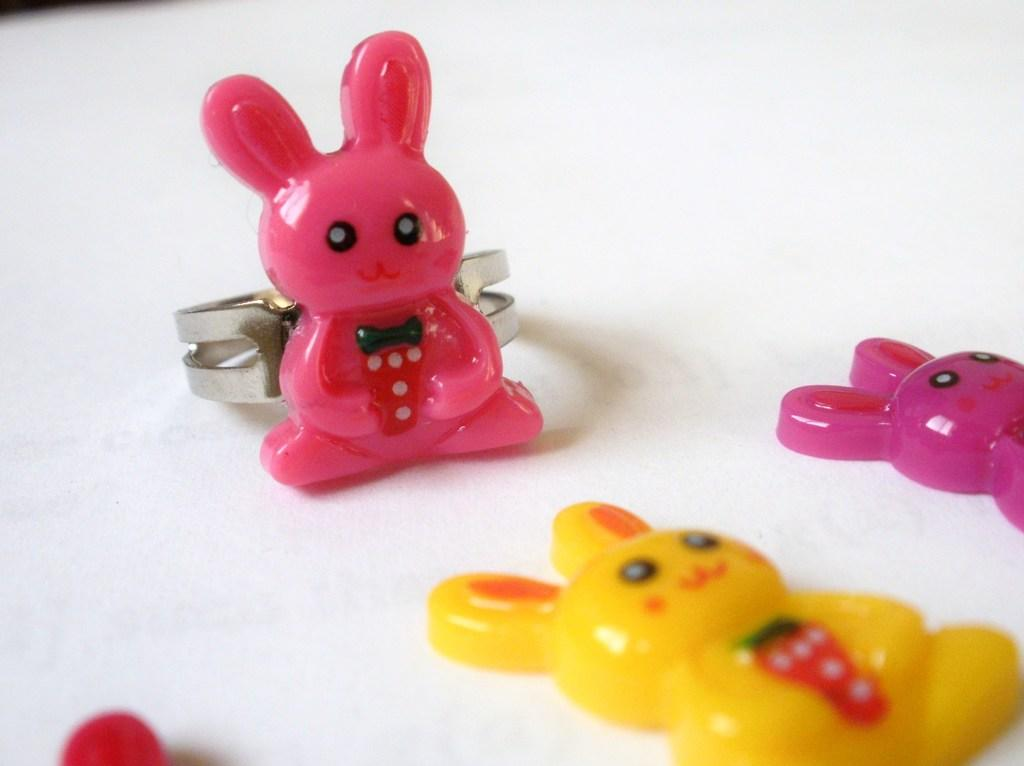What objects are at the bottom of the image? There are toys at the bottom of the image. Where are the toys located? The toys are on a surface. What color is the background of the image? The background of the image is white in color. How does the sail look in the image? There is no sail present in the image. What type of string is visible in the image? There is no string present in the image. 